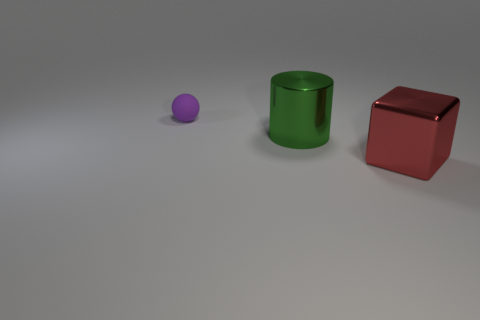If you had to guess, what is the purpose of this arrangement of objects? This arrangement of objects may serve as a visual exercise or a composition in a study of forms and colors. It could be part of an educational tool to teach about geometrical shapes, or it might be a simplistic artistic setup meant to convey a certain aesthetic or conceptual idea through the use of basic shapes and contrasting colors. 